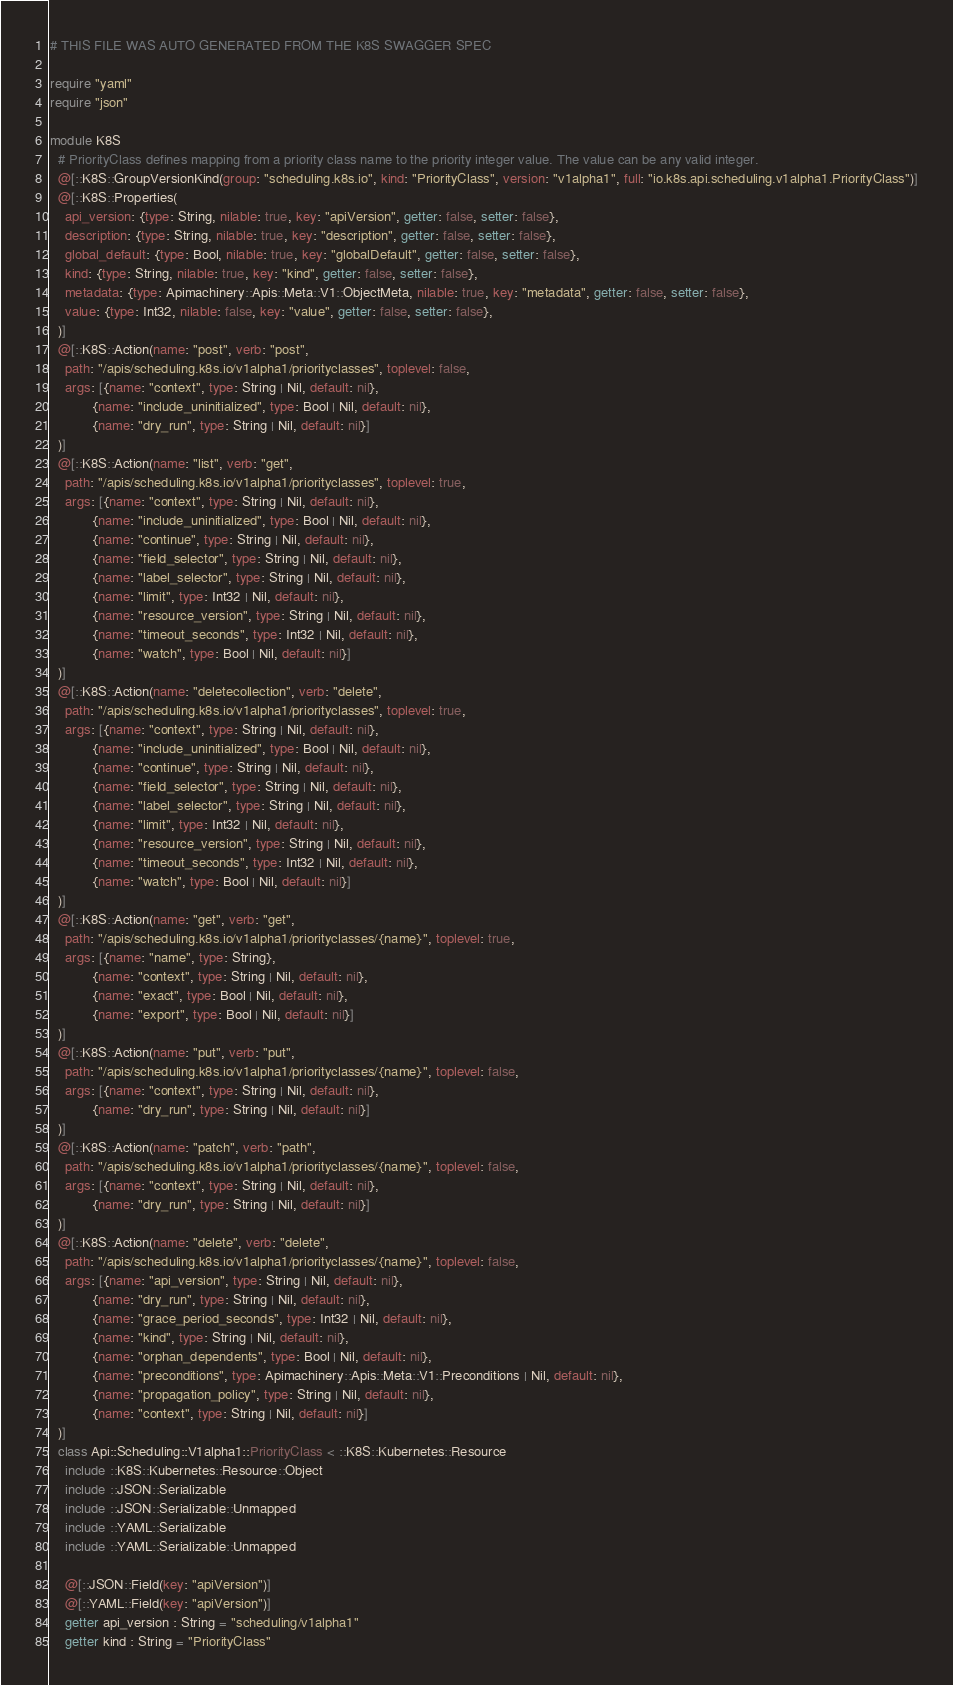Convert code to text. <code><loc_0><loc_0><loc_500><loc_500><_Crystal_># THIS FILE WAS AUTO GENERATED FROM THE K8S SWAGGER SPEC

require "yaml"
require "json"

module K8S
  # PriorityClass defines mapping from a priority class name to the priority integer value. The value can be any valid integer.
  @[::K8S::GroupVersionKind(group: "scheduling.k8s.io", kind: "PriorityClass", version: "v1alpha1", full: "io.k8s.api.scheduling.v1alpha1.PriorityClass")]
  @[::K8S::Properties(
    api_version: {type: String, nilable: true, key: "apiVersion", getter: false, setter: false},
    description: {type: String, nilable: true, key: "description", getter: false, setter: false},
    global_default: {type: Bool, nilable: true, key: "globalDefault", getter: false, setter: false},
    kind: {type: String, nilable: true, key: "kind", getter: false, setter: false},
    metadata: {type: Apimachinery::Apis::Meta::V1::ObjectMeta, nilable: true, key: "metadata", getter: false, setter: false},
    value: {type: Int32, nilable: false, key: "value", getter: false, setter: false},
  )]
  @[::K8S::Action(name: "post", verb: "post",
    path: "/apis/scheduling.k8s.io/v1alpha1/priorityclasses", toplevel: false,
    args: [{name: "context", type: String | Nil, default: nil},
           {name: "include_uninitialized", type: Bool | Nil, default: nil},
           {name: "dry_run", type: String | Nil, default: nil}]
  )]
  @[::K8S::Action(name: "list", verb: "get",
    path: "/apis/scheduling.k8s.io/v1alpha1/priorityclasses", toplevel: true,
    args: [{name: "context", type: String | Nil, default: nil},
           {name: "include_uninitialized", type: Bool | Nil, default: nil},
           {name: "continue", type: String | Nil, default: nil},
           {name: "field_selector", type: String | Nil, default: nil},
           {name: "label_selector", type: String | Nil, default: nil},
           {name: "limit", type: Int32 | Nil, default: nil},
           {name: "resource_version", type: String | Nil, default: nil},
           {name: "timeout_seconds", type: Int32 | Nil, default: nil},
           {name: "watch", type: Bool | Nil, default: nil}]
  )]
  @[::K8S::Action(name: "deletecollection", verb: "delete",
    path: "/apis/scheduling.k8s.io/v1alpha1/priorityclasses", toplevel: true,
    args: [{name: "context", type: String | Nil, default: nil},
           {name: "include_uninitialized", type: Bool | Nil, default: nil},
           {name: "continue", type: String | Nil, default: nil},
           {name: "field_selector", type: String | Nil, default: nil},
           {name: "label_selector", type: String | Nil, default: nil},
           {name: "limit", type: Int32 | Nil, default: nil},
           {name: "resource_version", type: String | Nil, default: nil},
           {name: "timeout_seconds", type: Int32 | Nil, default: nil},
           {name: "watch", type: Bool | Nil, default: nil}]
  )]
  @[::K8S::Action(name: "get", verb: "get",
    path: "/apis/scheduling.k8s.io/v1alpha1/priorityclasses/{name}", toplevel: true,
    args: [{name: "name", type: String},
           {name: "context", type: String | Nil, default: nil},
           {name: "exact", type: Bool | Nil, default: nil},
           {name: "export", type: Bool | Nil, default: nil}]
  )]
  @[::K8S::Action(name: "put", verb: "put",
    path: "/apis/scheduling.k8s.io/v1alpha1/priorityclasses/{name}", toplevel: false,
    args: [{name: "context", type: String | Nil, default: nil},
           {name: "dry_run", type: String | Nil, default: nil}]
  )]
  @[::K8S::Action(name: "patch", verb: "path",
    path: "/apis/scheduling.k8s.io/v1alpha1/priorityclasses/{name}", toplevel: false,
    args: [{name: "context", type: String | Nil, default: nil},
           {name: "dry_run", type: String | Nil, default: nil}]
  )]
  @[::K8S::Action(name: "delete", verb: "delete",
    path: "/apis/scheduling.k8s.io/v1alpha1/priorityclasses/{name}", toplevel: false,
    args: [{name: "api_version", type: String | Nil, default: nil},
           {name: "dry_run", type: String | Nil, default: nil},
           {name: "grace_period_seconds", type: Int32 | Nil, default: nil},
           {name: "kind", type: String | Nil, default: nil},
           {name: "orphan_dependents", type: Bool | Nil, default: nil},
           {name: "preconditions", type: Apimachinery::Apis::Meta::V1::Preconditions | Nil, default: nil},
           {name: "propagation_policy", type: String | Nil, default: nil},
           {name: "context", type: String | Nil, default: nil}]
  )]
  class Api::Scheduling::V1alpha1::PriorityClass < ::K8S::Kubernetes::Resource
    include ::K8S::Kubernetes::Resource::Object
    include ::JSON::Serializable
    include ::JSON::Serializable::Unmapped
    include ::YAML::Serializable
    include ::YAML::Serializable::Unmapped

    @[::JSON::Field(key: "apiVersion")]
    @[::YAML::Field(key: "apiVersion")]
    getter api_version : String = "scheduling/v1alpha1"
    getter kind : String = "PriorityClass"</code> 